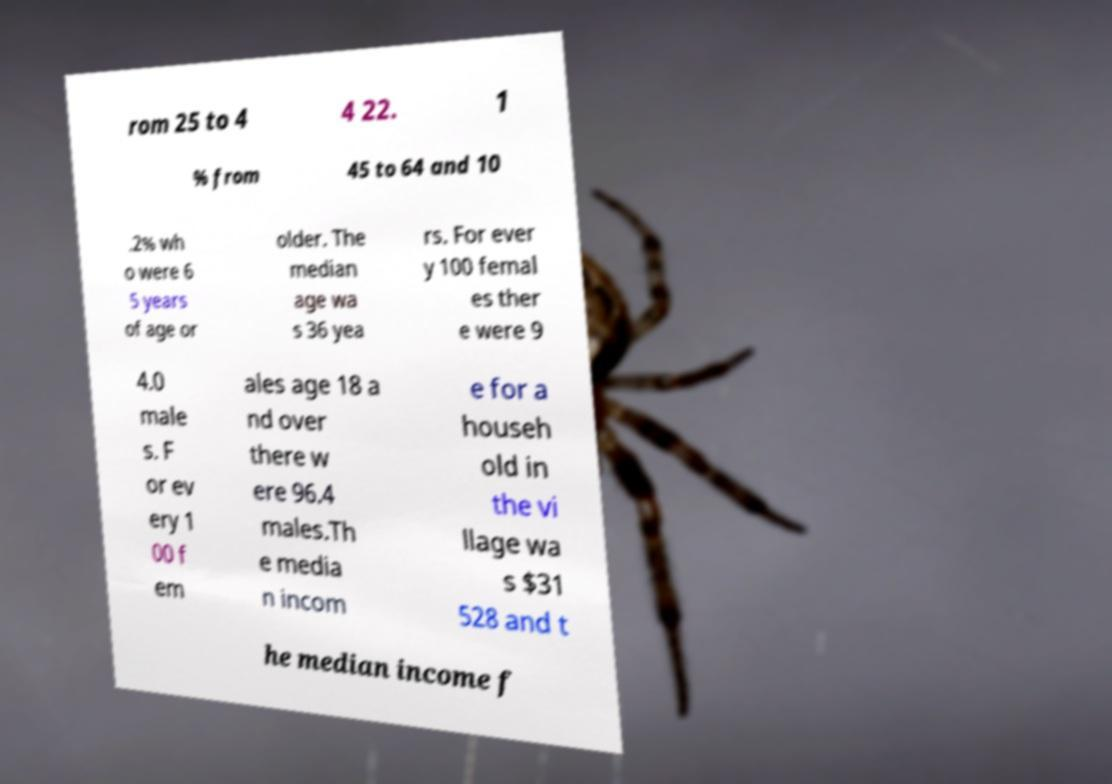There's text embedded in this image that I need extracted. Can you transcribe it verbatim? rom 25 to 4 4 22. 1 % from 45 to 64 and 10 .2% wh o were 6 5 years of age or older. The median age wa s 36 yea rs. For ever y 100 femal es ther e were 9 4.0 male s. F or ev ery 1 00 f em ales age 18 a nd over there w ere 96.4 males.Th e media n incom e for a househ old in the vi llage wa s $31 528 and t he median income f 